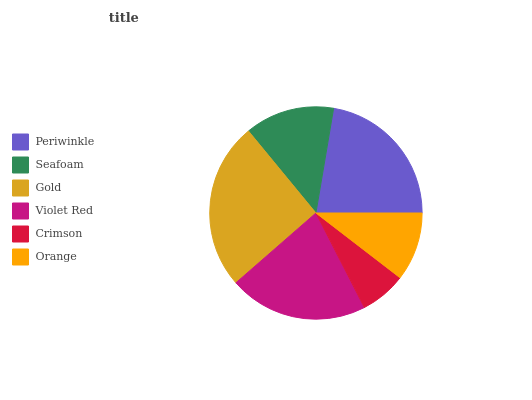Is Crimson the minimum?
Answer yes or no. Yes. Is Gold the maximum?
Answer yes or no. Yes. Is Seafoam the minimum?
Answer yes or no. No. Is Seafoam the maximum?
Answer yes or no. No. Is Periwinkle greater than Seafoam?
Answer yes or no. Yes. Is Seafoam less than Periwinkle?
Answer yes or no. Yes. Is Seafoam greater than Periwinkle?
Answer yes or no. No. Is Periwinkle less than Seafoam?
Answer yes or no. No. Is Violet Red the high median?
Answer yes or no. Yes. Is Seafoam the low median?
Answer yes or no. Yes. Is Seafoam the high median?
Answer yes or no. No. Is Orange the low median?
Answer yes or no. No. 